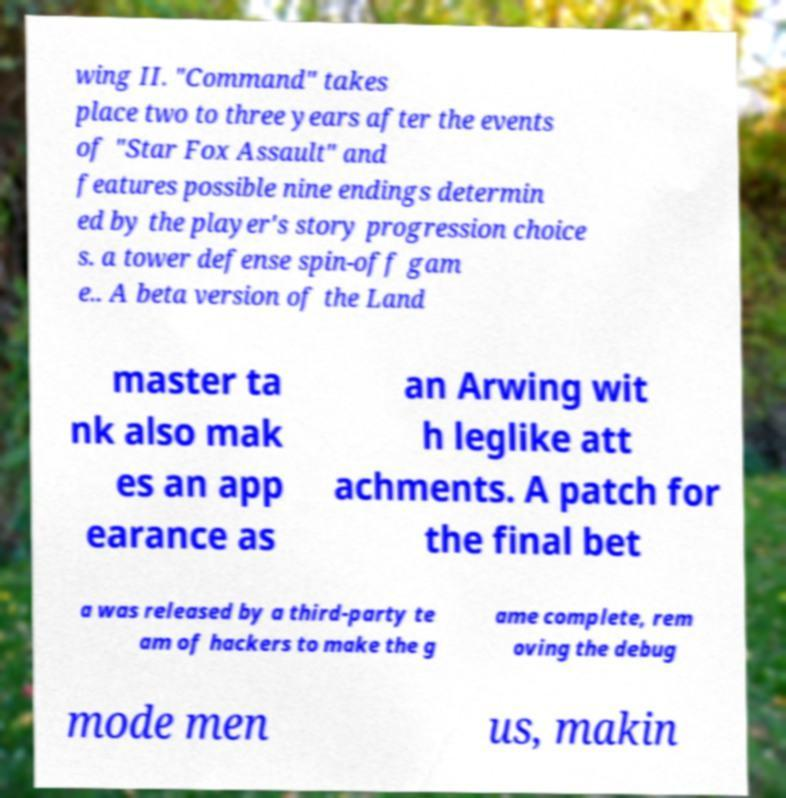What messages or text are displayed in this image? I need them in a readable, typed format. wing II. "Command" takes place two to three years after the events of "Star Fox Assault" and features possible nine endings determin ed by the player's story progression choice s. a tower defense spin-off gam e.. A beta version of the Land master ta nk also mak es an app earance as an Arwing wit h leglike att achments. A patch for the final bet a was released by a third-party te am of hackers to make the g ame complete, rem oving the debug mode men us, makin 